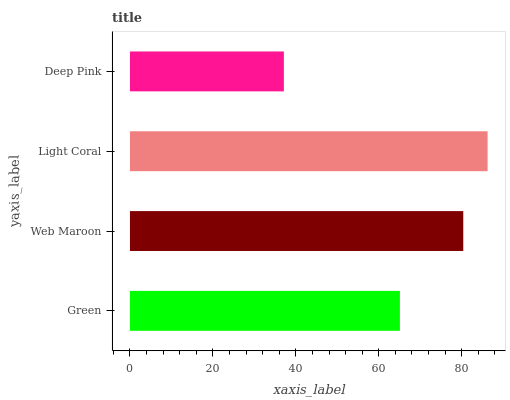Is Deep Pink the minimum?
Answer yes or no. Yes. Is Light Coral the maximum?
Answer yes or no. Yes. Is Web Maroon the minimum?
Answer yes or no. No. Is Web Maroon the maximum?
Answer yes or no. No. Is Web Maroon greater than Green?
Answer yes or no. Yes. Is Green less than Web Maroon?
Answer yes or no. Yes. Is Green greater than Web Maroon?
Answer yes or no. No. Is Web Maroon less than Green?
Answer yes or no. No. Is Web Maroon the high median?
Answer yes or no. Yes. Is Green the low median?
Answer yes or no. Yes. Is Green the high median?
Answer yes or no. No. Is Deep Pink the low median?
Answer yes or no. No. 